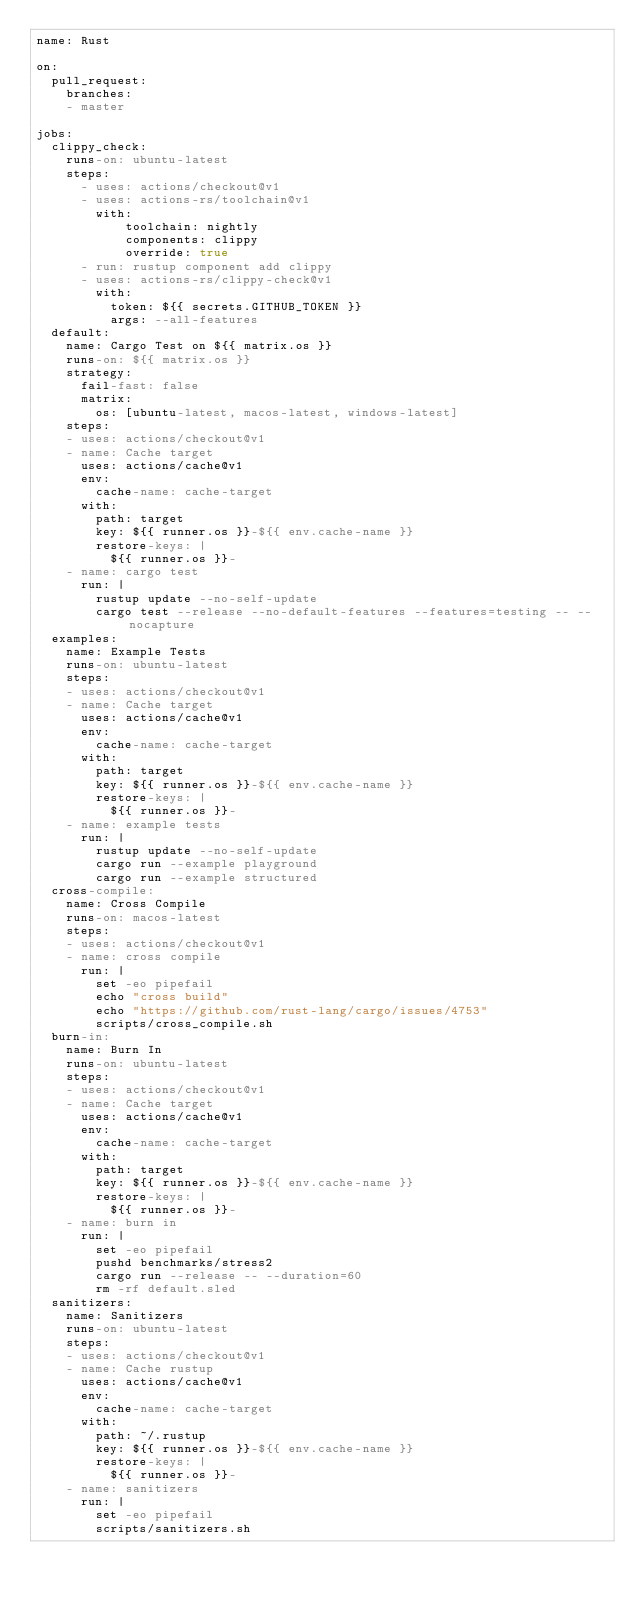Convert code to text. <code><loc_0><loc_0><loc_500><loc_500><_YAML_>name: Rust

on:
  pull_request:
    branches:
    - master

jobs:
  clippy_check:
    runs-on: ubuntu-latest
    steps:
      - uses: actions/checkout@v1
      - uses: actions-rs/toolchain@v1
        with:
            toolchain: nightly
            components: clippy
            override: true
      - run: rustup component add clippy
      - uses: actions-rs/clippy-check@v1
        with:
          token: ${{ secrets.GITHUB_TOKEN }}
          args: --all-features
  default:
    name: Cargo Test on ${{ matrix.os }}
    runs-on: ${{ matrix.os }}
    strategy:
      fail-fast: false
      matrix:
        os: [ubuntu-latest, macos-latest, windows-latest]
    steps:
    - uses: actions/checkout@v1
    - name: Cache target
      uses: actions/cache@v1
      env:
        cache-name: cache-target
      with:
        path: target
        key: ${{ runner.os }}-${{ env.cache-name }}
        restore-keys: |
          ${{ runner.os }}-
    - name: cargo test
      run: |
        rustup update --no-self-update
        cargo test --release --no-default-features --features=testing -- --nocapture
  examples:
    name: Example Tests
    runs-on: ubuntu-latest
    steps:
    - uses: actions/checkout@v1
    - name: Cache target
      uses: actions/cache@v1
      env:
        cache-name: cache-target
      with:
        path: target
        key: ${{ runner.os }}-${{ env.cache-name }}
        restore-keys: |
          ${{ runner.os }}-
    - name: example tests
      run: |
        rustup update --no-self-update
        cargo run --example playground
        cargo run --example structured
  cross-compile:
    name: Cross Compile
    runs-on: macos-latest
    steps:
    - uses: actions/checkout@v1
    - name: cross compile
      run: |
        set -eo pipefail
        echo "cross build"
        echo "https://github.com/rust-lang/cargo/issues/4753"
        scripts/cross_compile.sh
  burn-in:
    name: Burn In
    runs-on: ubuntu-latest
    steps:
    - uses: actions/checkout@v1
    - name: Cache target
      uses: actions/cache@v1
      env:
        cache-name: cache-target
      with:
        path: target
        key: ${{ runner.os }}-${{ env.cache-name }}
        restore-keys: |
          ${{ runner.os }}-
    - name: burn in
      run: |
        set -eo pipefail
        pushd benchmarks/stress2
        cargo run --release -- --duration=60
        rm -rf default.sled
  sanitizers:
    name: Sanitizers
    runs-on: ubuntu-latest
    steps:
    - uses: actions/checkout@v1
    - name: Cache rustup
      uses: actions/cache@v1
      env:
        cache-name: cache-target
      with:
        path: ~/.rustup
        key: ${{ runner.os }}-${{ env.cache-name }}
        restore-keys: |
          ${{ runner.os }}-
    - name: sanitizers
      run: |
        set -eo pipefail
        scripts/sanitizers.sh
</code> 